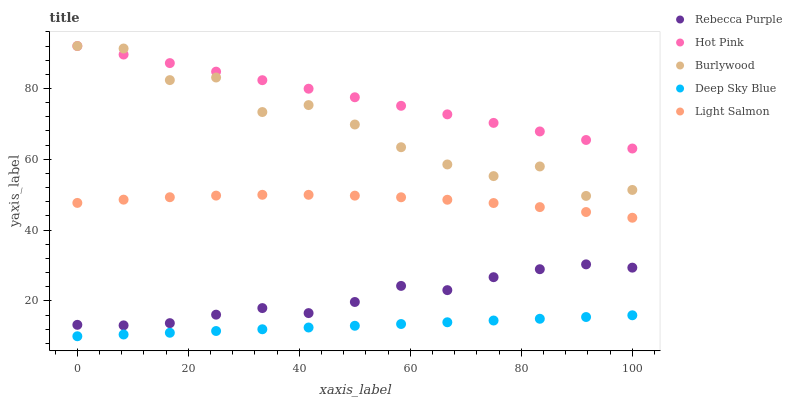Does Deep Sky Blue have the minimum area under the curve?
Answer yes or no. Yes. Does Hot Pink have the maximum area under the curve?
Answer yes or no. Yes. Does Light Salmon have the minimum area under the curve?
Answer yes or no. No. Does Light Salmon have the maximum area under the curve?
Answer yes or no. No. Is Deep Sky Blue the smoothest?
Answer yes or no. Yes. Is Burlywood the roughest?
Answer yes or no. Yes. Is Light Salmon the smoothest?
Answer yes or no. No. Is Light Salmon the roughest?
Answer yes or no. No. Does Deep Sky Blue have the lowest value?
Answer yes or no. Yes. Does Light Salmon have the lowest value?
Answer yes or no. No. Does Hot Pink have the highest value?
Answer yes or no. Yes. Does Light Salmon have the highest value?
Answer yes or no. No. Is Deep Sky Blue less than Burlywood?
Answer yes or no. Yes. Is Burlywood greater than Deep Sky Blue?
Answer yes or no. Yes. Does Hot Pink intersect Burlywood?
Answer yes or no. Yes. Is Hot Pink less than Burlywood?
Answer yes or no. No. Is Hot Pink greater than Burlywood?
Answer yes or no. No. Does Deep Sky Blue intersect Burlywood?
Answer yes or no. No. 